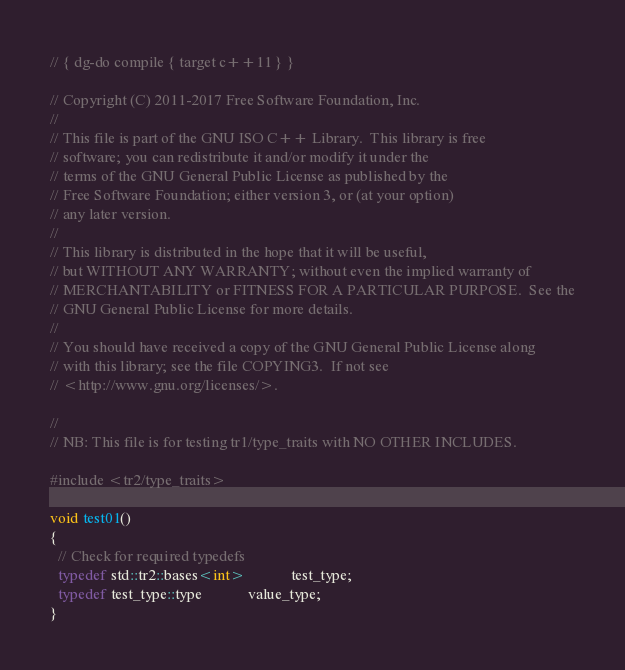<code> <loc_0><loc_0><loc_500><loc_500><_C++_>// { dg-do compile { target c++11 } }

// Copyright (C) 2011-2017 Free Software Foundation, Inc.
//
// This file is part of the GNU ISO C++ Library.  This library is free
// software; you can redistribute it and/or modify it under the
// terms of the GNU General Public License as published by the
// Free Software Foundation; either version 3, or (at your option)
// any later version.
//
// This library is distributed in the hope that it will be useful,
// but WITHOUT ANY WARRANTY; without even the implied warranty of
// MERCHANTABILITY or FITNESS FOR A PARTICULAR PURPOSE.  See the
// GNU General Public License for more details.
//
// You should have received a copy of the GNU General Public License along
// with this library; see the file COPYING3.  If not see
// <http://www.gnu.org/licenses/>.

// 
// NB: This file is for testing tr1/type_traits with NO OTHER INCLUDES.

#include <tr2/type_traits>

void test01()
{
  // Check for required typedefs
  typedef std::tr2::bases<int>            test_type;
  typedef test_type::type            value_type;
}
</code> 